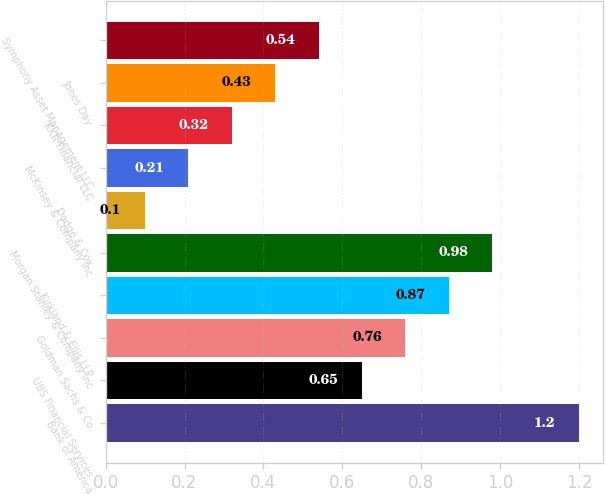Convert chart. <chart><loc_0><loc_0><loc_500><loc_500><bar_chart><fcel>Bank of America<fcel>UBS Financial Services<fcel>Goldman Sachs & Co<fcel>Kirkland & Ellis LLP<fcel>Morgan Stanley & Company Inc<fcel>Dodge & Cox<fcel>McKinsey & Company Inc<fcel>KKR Financial LLC<fcel>Jones Day<fcel>Symphony Asset Management LLC<nl><fcel>1.2<fcel>0.65<fcel>0.76<fcel>0.87<fcel>0.98<fcel>0.1<fcel>0.21<fcel>0.32<fcel>0.43<fcel>0.54<nl></chart> 